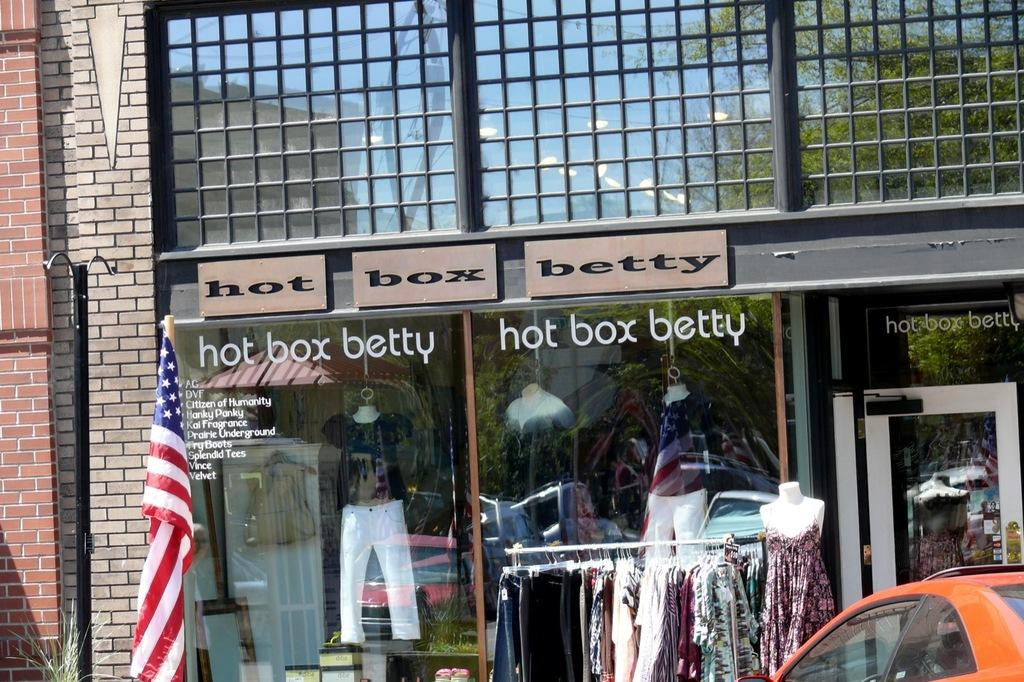What type of structure can be seen in the image? There is a building in the image. What is attached to the pole in the image? There is a flag attached to the pole in the image. What is the purpose of the clothes with a stand in the image? The clothes with a stand are likely for display or drying purposes. What is the mannequin wearing in the image? The mannequin is wearing a dress in the image. What type of vehicle is present in the image? There is a car in the image. What is the glass in the image used for? The glass in the image has a reflection, which suggests it is a window or mirror. What are the boards in the image used for? The boards in the image could be used for construction or signage purposes. Where is the governor sitting on the throne in the image? There is no governor or throne present in the image. What type of mailbox can be seen near the car in the image? There is no mailbox present in the image. 